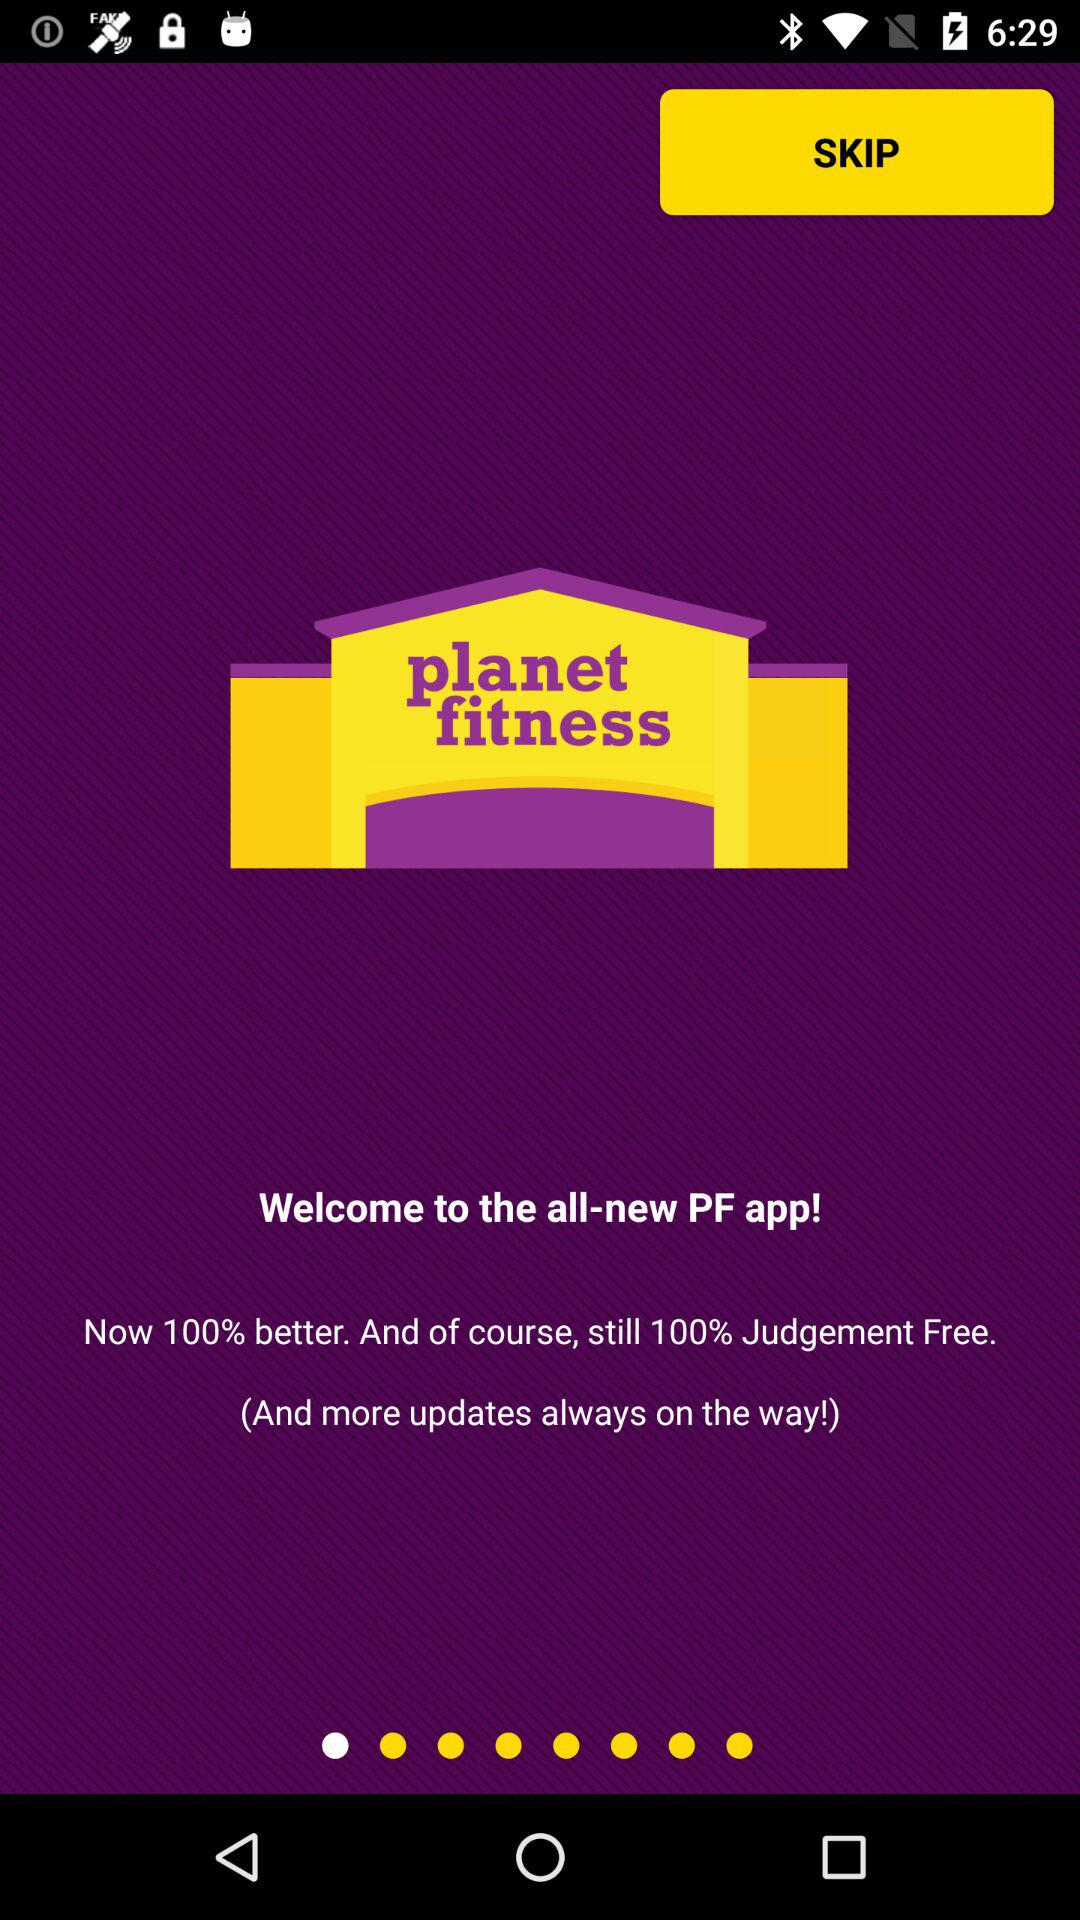What is the name of the application? The name of the application is "planet fitness". 